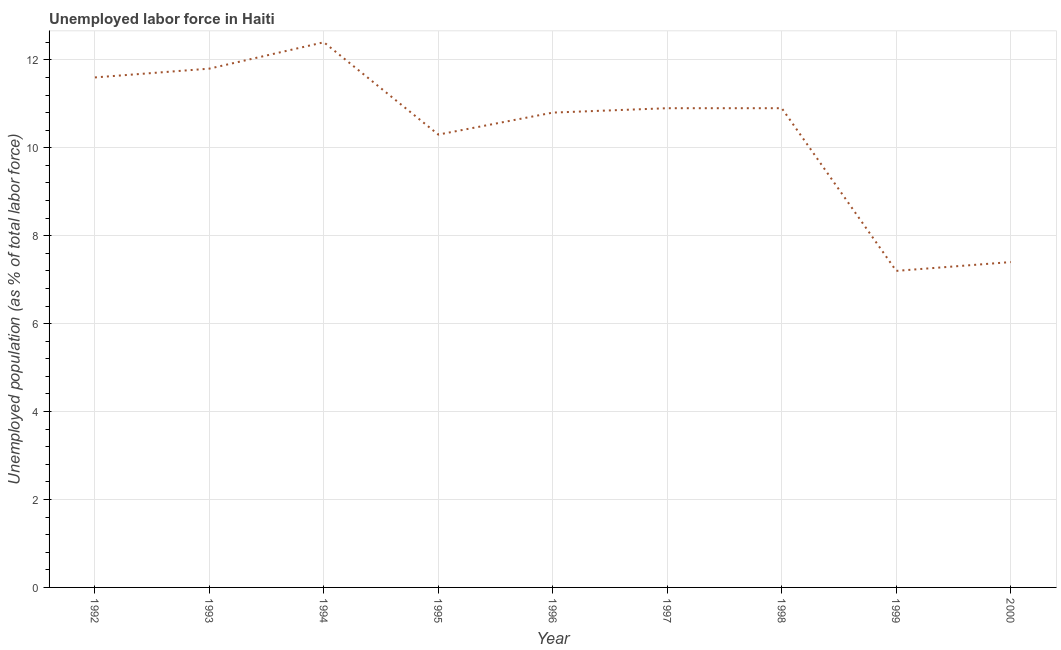What is the total unemployed population in 1995?
Offer a terse response. 10.3. Across all years, what is the maximum total unemployed population?
Offer a very short reply. 12.4. Across all years, what is the minimum total unemployed population?
Your answer should be compact. 7.2. In which year was the total unemployed population maximum?
Provide a short and direct response. 1994. In which year was the total unemployed population minimum?
Offer a very short reply. 1999. What is the sum of the total unemployed population?
Ensure brevity in your answer.  93.3. What is the difference between the total unemployed population in 1996 and 2000?
Offer a very short reply. 3.4. What is the average total unemployed population per year?
Make the answer very short. 10.37. What is the median total unemployed population?
Keep it short and to the point. 10.9. What is the ratio of the total unemployed population in 1994 to that in 1995?
Make the answer very short. 1.2. Is the difference between the total unemployed population in 1993 and 1997 greater than the difference between any two years?
Give a very brief answer. No. What is the difference between the highest and the second highest total unemployed population?
Provide a succinct answer. 0.6. What is the difference between the highest and the lowest total unemployed population?
Make the answer very short. 5.2. In how many years, is the total unemployed population greater than the average total unemployed population taken over all years?
Give a very brief answer. 6. Does the total unemployed population monotonically increase over the years?
Offer a terse response. No. How many lines are there?
Keep it short and to the point. 1. How many years are there in the graph?
Provide a short and direct response. 9. What is the difference between two consecutive major ticks on the Y-axis?
Make the answer very short. 2. What is the title of the graph?
Provide a short and direct response. Unemployed labor force in Haiti. What is the label or title of the X-axis?
Give a very brief answer. Year. What is the label or title of the Y-axis?
Your answer should be very brief. Unemployed population (as % of total labor force). What is the Unemployed population (as % of total labor force) in 1992?
Your response must be concise. 11.6. What is the Unemployed population (as % of total labor force) of 1993?
Your answer should be very brief. 11.8. What is the Unemployed population (as % of total labor force) in 1994?
Ensure brevity in your answer.  12.4. What is the Unemployed population (as % of total labor force) in 1995?
Your answer should be compact. 10.3. What is the Unemployed population (as % of total labor force) in 1996?
Offer a very short reply. 10.8. What is the Unemployed population (as % of total labor force) in 1997?
Keep it short and to the point. 10.9. What is the Unemployed population (as % of total labor force) of 1998?
Provide a short and direct response. 10.9. What is the Unemployed population (as % of total labor force) of 1999?
Make the answer very short. 7.2. What is the Unemployed population (as % of total labor force) in 2000?
Provide a succinct answer. 7.4. What is the difference between the Unemployed population (as % of total labor force) in 1992 and 1993?
Provide a short and direct response. -0.2. What is the difference between the Unemployed population (as % of total labor force) in 1992 and 1994?
Your answer should be compact. -0.8. What is the difference between the Unemployed population (as % of total labor force) in 1992 and 1995?
Make the answer very short. 1.3. What is the difference between the Unemployed population (as % of total labor force) in 1992 and 1996?
Your response must be concise. 0.8. What is the difference between the Unemployed population (as % of total labor force) in 1992 and 1997?
Make the answer very short. 0.7. What is the difference between the Unemployed population (as % of total labor force) in 1992 and 1998?
Offer a terse response. 0.7. What is the difference between the Unemployed population (as % of total labor force) in 1992 and 1999?
Give a very brief answer. 4.4. What is the difference between the Unemployed population (as % of total labor force) in 1993 and 1995?
Keep it short and to the point. 1.5. What is the difference between the Unemployed population (as % of total labor force) in 1993 and 1997?
Make the answer very short. 0.9. What is the difference between the Unemployed population (as % of total labor force) in 1993 and 1998?
Offer a very short reply. 0.9. What is the difference between the Unemployed population (as % of total labor force) in 1993 and 2000?
Provide a succinct answer. 4.4. What is the difference between the Unemployed population (as % of total labor force) in 1994 and 1995?
Provide a succinct answer. 2.1. What is the difference between the Unemployed population (as % of total labor force) in 1994 and 1996?
Your answer should be compact. 1.6. What is the difference between the Unemployed population (as % of total labor force) in 1994 and 1998?
Your answer should be compact. 1.5. What is the difference between the Unemployed population (as % of total labor force) in 1994 and 1999?
Give a very brief answer. 5.2. What is the difference between the Unemployed population (as % of total labor force) in 1994 and 2000?
Offer a very short reply. 5. What is the difference between the Unemployed population (as % of total labor force) in 1996 and 1999?
Your response must be concise. 3.6. What is the difference between the Unemployed population (as % of total labor force) in 1997 and 1999?
Keep it short and to the point. 3.7. What is the difference between the Unemployed population (as % of total labor force) in 1997 and 2000?
Give a very brief answer. 3.5. What is the difference between the Unemployed population (as % of total labor force) in 1998 and 1999?
Provide a short and direct response. 3.7. What is the difference between the Unemployed population (as % of total labor force) in 1999 and 2000?
Offer a terse response. -0.2. What is the ratio of the Unemployed population (as % of total labor force) in 1992 to that in 1993?
Ensure brevity in your answer.  0.98. What is the ratio of the Unemployed population (as % of total labor force) in 1992 to that in 1994?
Offer a very short reply. 0.94. What is the ratio of the Unemployed population (as % of total labor force) in 1992 to that in 1995?
Keep it short and to the point. 1.13. What is the ratio of the Unemployed population (as % of total labor force) in 1992 to that in 1996?
Provide a succinct answer. 1.07. What is the ratio of the Unemployed population (as % of total labor force) in 1992 to that in 1997?
Offer a terse response. 1.06. What is the ratio of the Unemployed population (as % of total labor force) in 1992 to that in 1998?
Make the answer very short. 1.06. What is the ratio of the Unemployed population (as % of total labor force) in 1992 to that in 1999?
Ensure brevity in your answer.  1.61. What is the ratio of the Unemployed population (as % of total labor force) in 1992 to that in 2000?
Provide a short and direct response. 1.57. What is the ratio of the Unemployed population (as % of total labor force) in 1993 to that in 1994?
Your answer should be very brief. 0.95. What is the ratio of the Unemployed population (as % of total labor force) in 1993 to that in 1995?
Give a very brief answer. 1.15. What is the ratio of the Unemployed population (as % of total labor force) in 1993 to that in 1996?
Offer a very short reply. 1.09. What is the ratio of the Unemployed population (as % of total labor force) in 1993 to that in 1997?
Give a very brief answer. 1.08. What is the ratio of the Unemployed population (as % of total labor force) in 1993 to that in 1998?
Give a very brief answer. 1.08. What is the ratio of the Unemployed population (as % of total labor force) in 1993 to that in 1999?
Your answer should be very brief. 1.64. What is the ratio of the Unemployed population (as % of total labor force) in 1993 to that in 2000?
Your answer should be very brief. 1.59. What is the ratio of the Unemployed population (as % of total labor force) in 1994 to that in 1995?
Ensure brevity in your answer.  1.2. What is the ratio of the Unemployed population (as % of total labor force) in 1994 to that in 1996?
Make the answer very short. 1.15. What is the ratio of the Unemployed population (as % of total labor force) in 1994 to that in 1997?
Provide a succinct answer. 1.14. What is the ratio of the Unemployed population (as % of total labor force) in 1994 to that in 1998?
Provide a succinct answer. 1.14. What is the ratio of the Unemployed population (as % of total labor force) in 1994 to that in 1999?
Provide a succinct answer. 1.72. What is the ratio of the Unemployed population (as % of total labor force) in 1994 to that in 2000?
Provide a short and direct response. 1.68. What is the ratio of the Unemployed population (as % of total labor force) in 1995 to that in 1996?
Provide a short and direct response. 0.95. What is the ratio of the Unemployed population (as % of total labor force) in 1995 to that in 1997?
Offer a very short reply. 0.94. What is the ratio of the Unemployed population (as % of total labor force) in 1995 to that in 1998?
Your response must be concise. 0.94. What is the ratio of the Unemployed population (as % of total labor force) in 1995 to that in 1999?
Your response must be concise. 1.43. What is the ratio of the Unemployed population (as % of total labor force) in 1995 to that in 2000?
Your answer should be compact. 1.39. What is the ratio of the Unemployed population (as % of total labor force) in 1996 to that in 1997?
Provide a short and direct response. 0.99. What is the ratio of the Unemployed population (as % of total labor force) in 1996 to that in 1999?
Offer a very short reply. 1.5. What is the ratio of the Unemployed population (as % of total labor force) in 1996 to that in 2000?
Ensure brevity in your answer.  1.46. What is the ratio of the Unemployed population (as % of total labor force) in 1997 to that in 1999?
Offer a very short reply. 1.51. What is the ratio of the Unemployed population (as % of total labor force) in 1997 to that in 2000?
Your response must be concise. 1.47. What is the ratio of the Unemployed population (as % of total labor force) in 1998 to that in 1999?
Ensure brevity in your answer.  1.51. What is the ratio of the Unemployed population (as % of total labor force) in 1998 to that in 2000?
Your answer should be very brief. 1.47. 